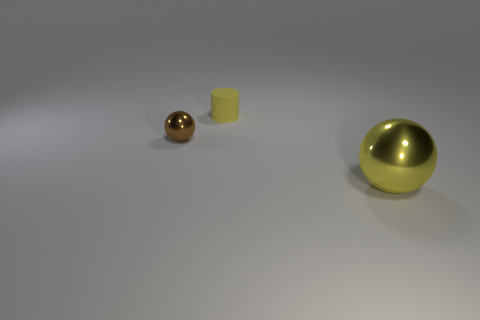Is there anything else that is the same size as the yellow metallic ball?
Make the answer very short. No. Is there a brown thing?
Provide a succinct answer. Yes. Are there any metallic spheres in front of the tiny thing right of the shiny ball to the left of the large yellow shiny thing?
Keep it short and to the point. Yes. How many big things are either spheres or yellow cylinders?
Keep it short and to the point. 1. There is a metal thing that is the same size as the rubber thing; what is its color?
Provide a short and direct response. Brown. There is a brown object; what number of small yellow matte cylinders are to the right of it?
Keep it short and to the point. 1. Is there another sphere that has the same material as the small ball?
Your response must be concise. Yes. The tiny matte object that is the same color as the large object is what shape?
Offer a terse response. Cylinder. The sphere in front of the tiny metallic ball is what color?
Give a very brief answer. Yellow. Are there the same number of balls in front of the brown ball and large yellow metal balls that are behind the small cylinder?
Ensure brevity in your answer.  No. 